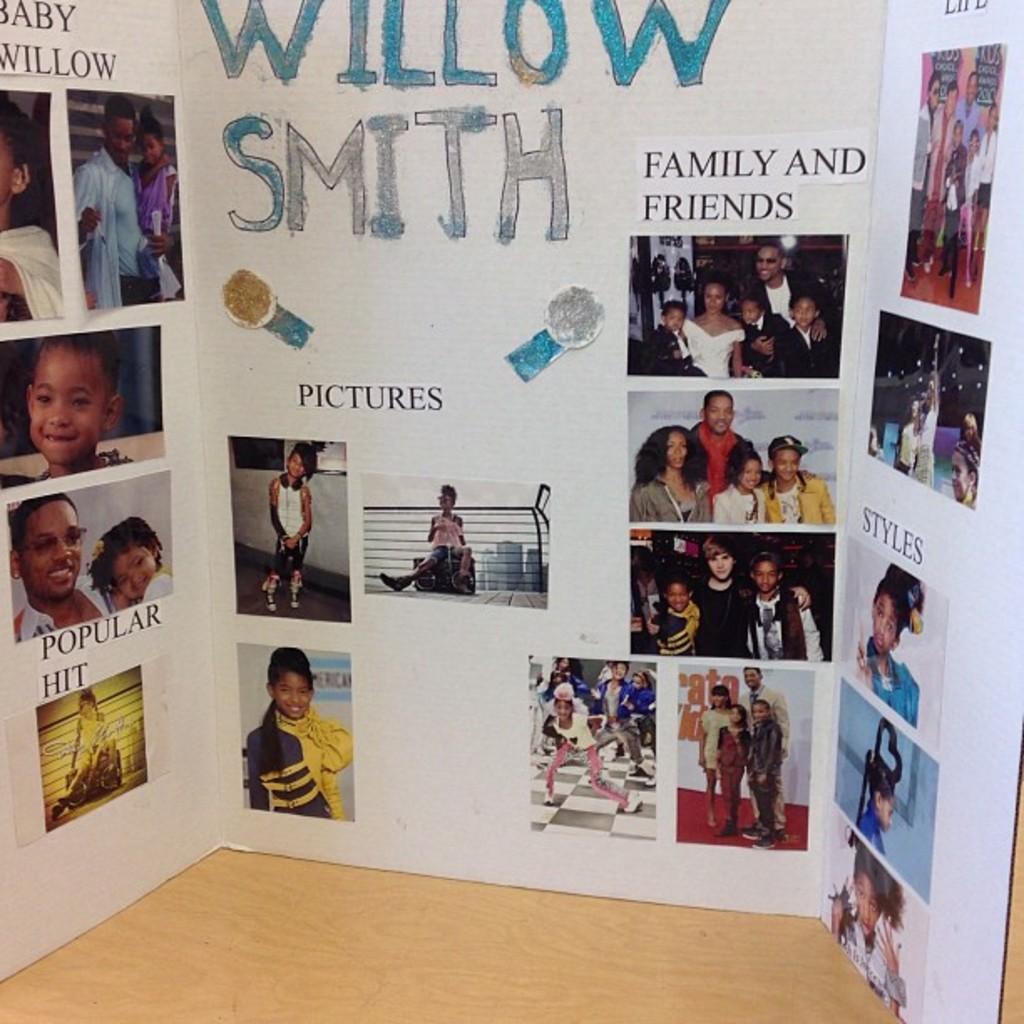In one or two sentences, can you explain what this image depicts? In this picture there is a board and there are pictures of people and there is a text on the board. At the bottom there is a wooden floor. 